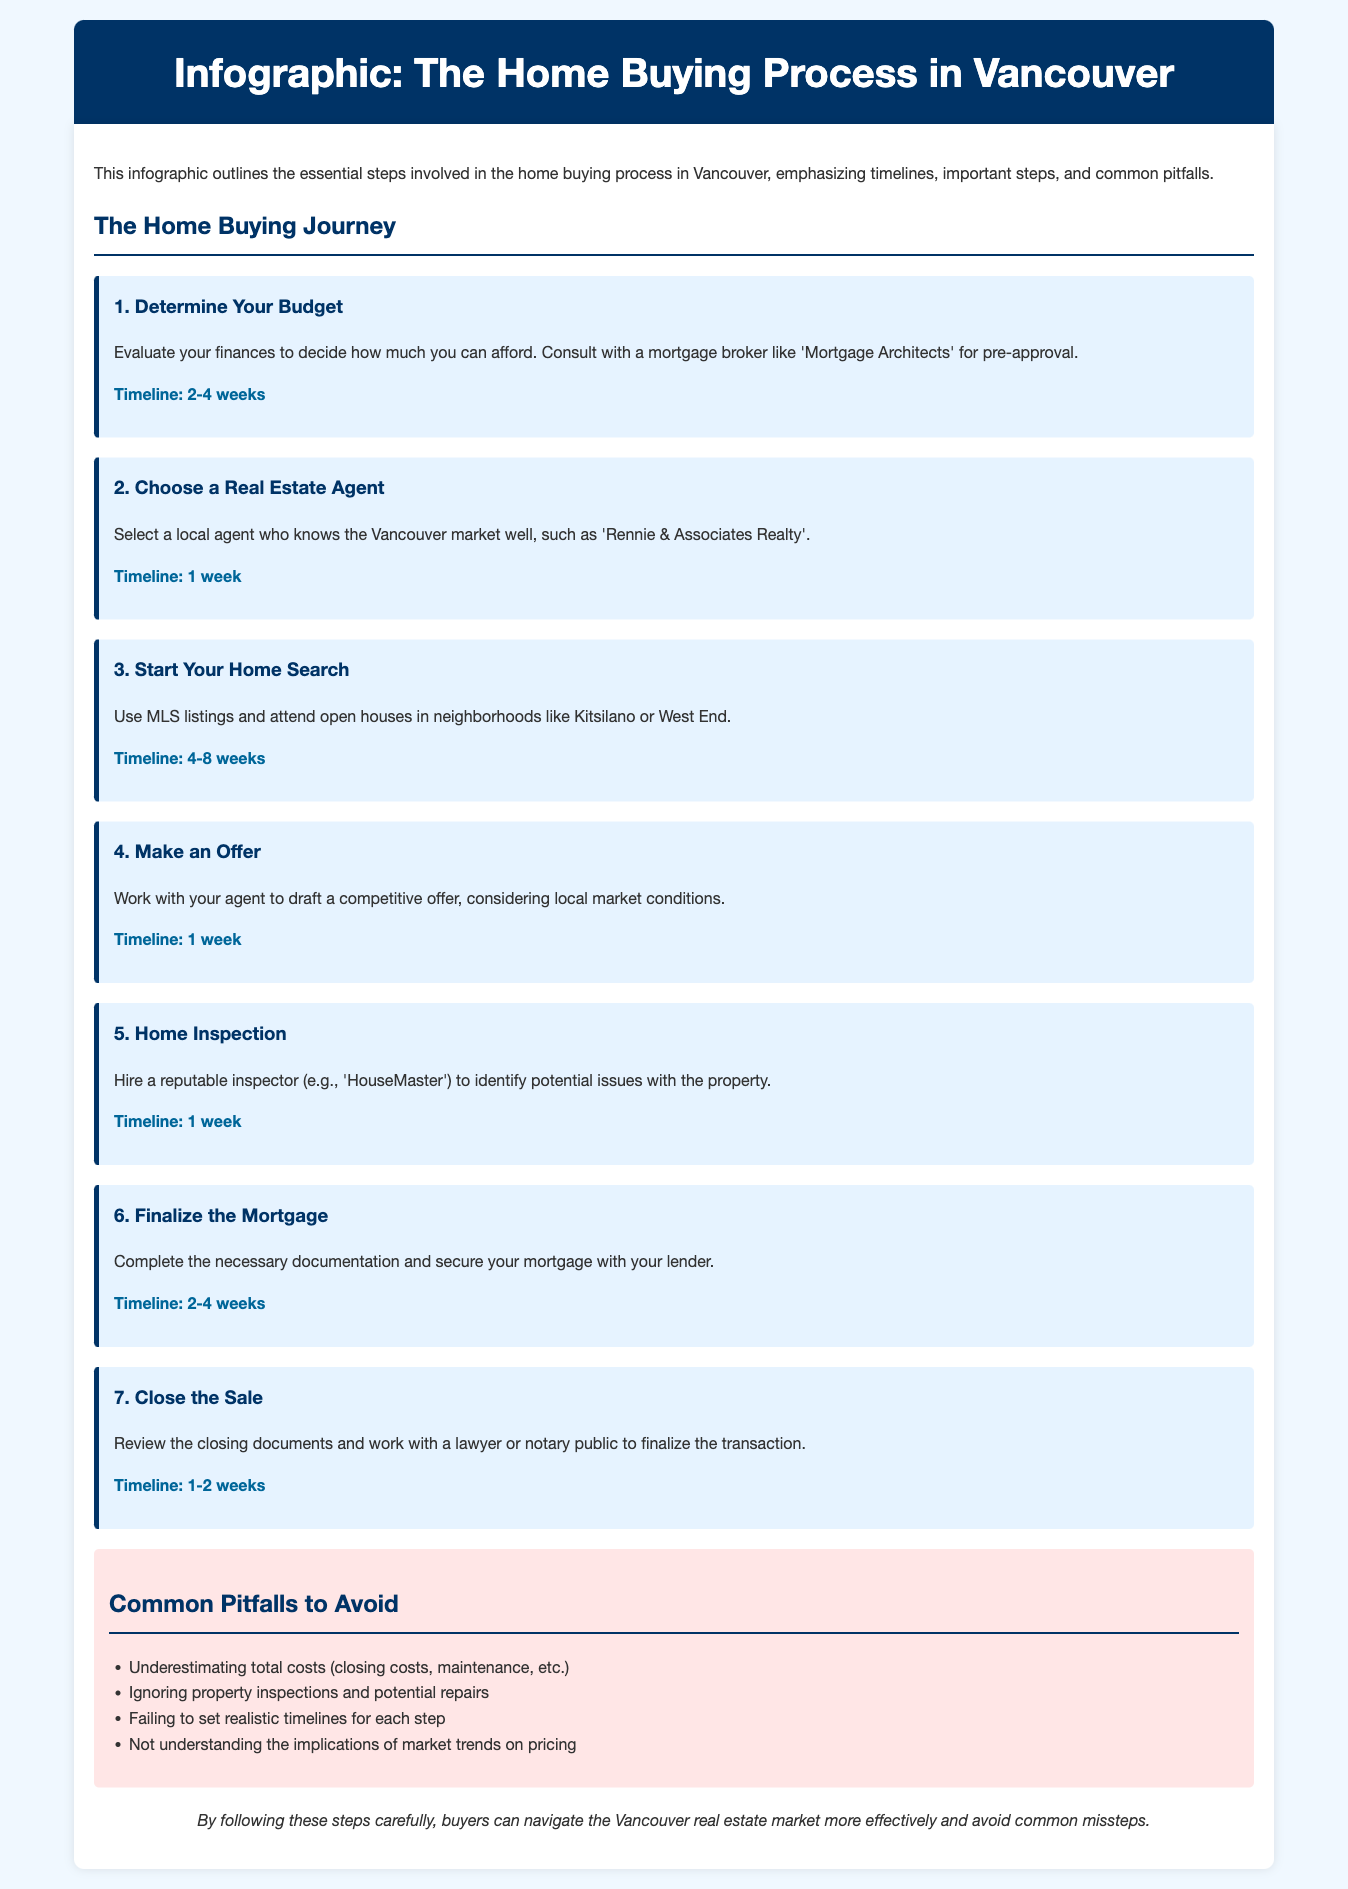What is the first step in the home buying process? The first step is to determine your budget and evaluate finances.
Answer: Determine Your Budget How long does it typically take to complete the home inspection? The timeline for the home inspection step is provided in the document.
Answer: 1 week Who can help secure a mortgage in Vancouver? The document suggests consulting a mortgage broker for pre-approval.
Answer: Mortgage Architects What is a common pitfall to avoid when buying a home? The document lists several pitfalls buyers should be aware of.
Answer: Underestimating total costs How many steps are outlined in the home buying process? The infographic details each step of the process, allowing for easy counting.
Answer: 7 steps What is the timeline for choosing a real estate agent? The document specifies a timeline for selecting an agent to guide buyers.
Answer: 1 week In which neighborhoods should potential buyers consider looking for homes? The document suggests specific neighborhoods of interest.
Answer: Kitsilano or West End What should buyers do before making an offer? The document mentions drafting a competitive offer considering local conditions.
Answer: Work with your agent What role does a lawyer or notary public play in the closing process? The document indicates the involvement of legal professionals in completing the sale.
Answer: Finalize the transaction 